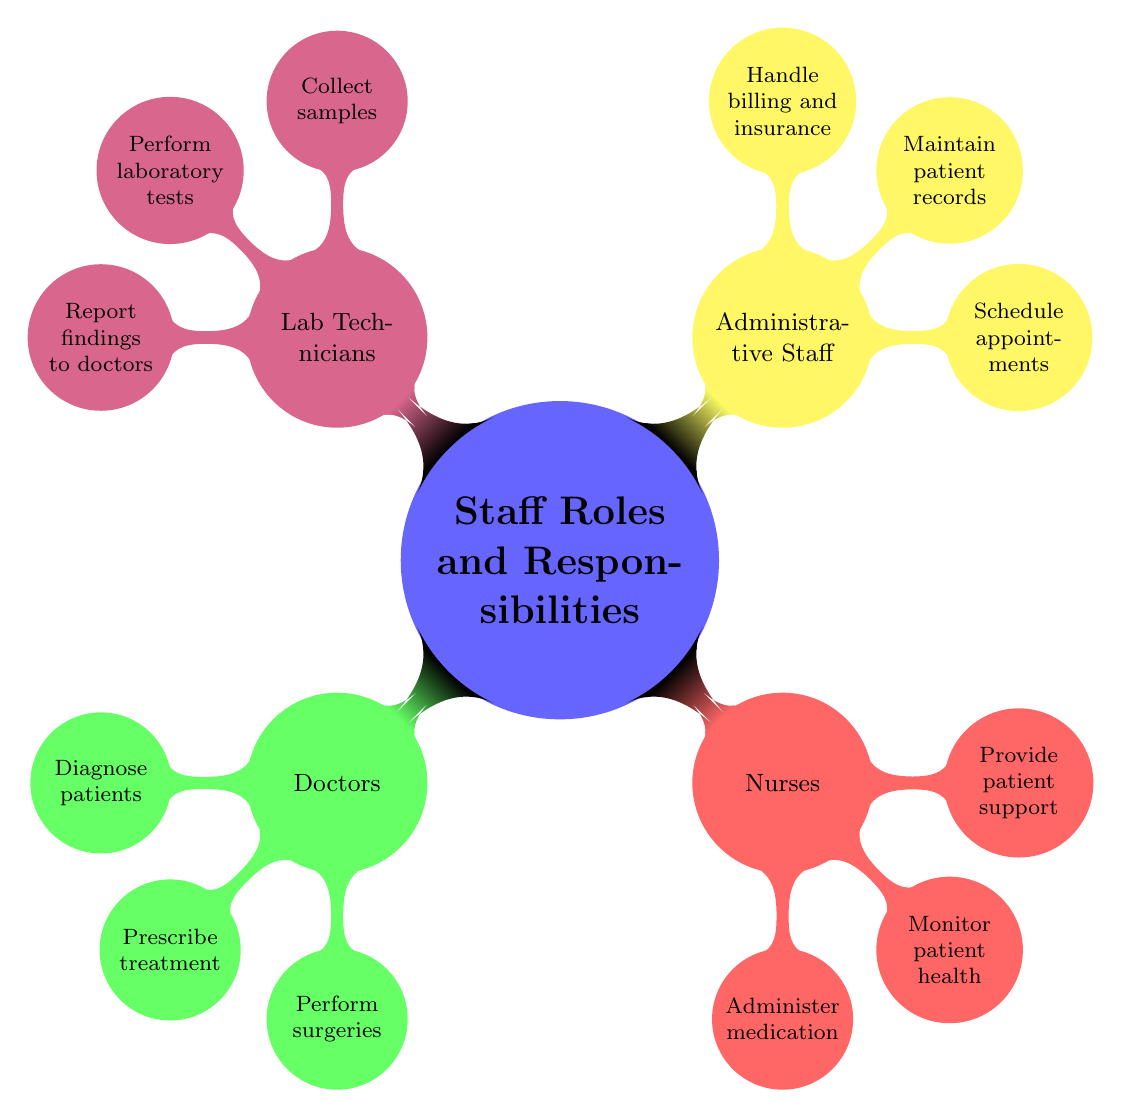What's the role of Nurses? The diagram indicates that Nurses assist doctors and care for patients. This is gathered from the node titled "Nurses," which explicitly states their role.
Answer: Assist doctors and care for patients How many main staff roles are represented in the diagram? By counting the main nodes branching from "Staff Roles and Responsibilities," we see there are four main roles: Doctors, Nurses, Administrative Staff, and Lab Technicians.
Answer: 4 List one responsibility of Lab Technicians. The diagram shows that one responsibility of Lab Technicians is to report findings to doctors, which can be directly observed in the node related to Lab Technicians.
Answer: Report findings to doctors What are the three responsibilities of Administrative Staff? The diagram displays three distinct responsibilities under Administrative Staff: schedule appointments, maintain patient records, and handle billing and insurance. These responsibilities are listed directly below the Administrative Staff node.
Answer: Schedule appointments, maintain patient records, handle billing and insurance Which role has the responsibility to perform surgeries? From the diagram, it is clear that only Doctors have the responsibility to perform surgeries, as this is specifically listed under the Doctors’ responsibilities.
Answer: Doctors What is the primary role of Lab Technicians? The primary role of Lab Technicians, as noted in the diagram, is to conduct tests and analyze results. This information is found in the main description node for Lab Technicians.
Answer: Conduct tests and analyze results How many responsibilities do Nurses have listed in the diagram? By examining the node for Nurses, we find that there are three listed responsibilities: administer medication, monitor patient health, and provide patient support. Counting these gives us the answer.
Answer: 3 What role is responsible for maintaining patient records? The diagram points out that maintaining patient records is a responsibility of Administrative Staff, as it is one of the listed tasks under that node.
Answer: Administrative Staff Which staff role is responsible for collecting samples? The diagram indicates that collecting samples is a responsibility of Lab Technicians, which can be found under their designated node.
Answer: Lab Technicians 